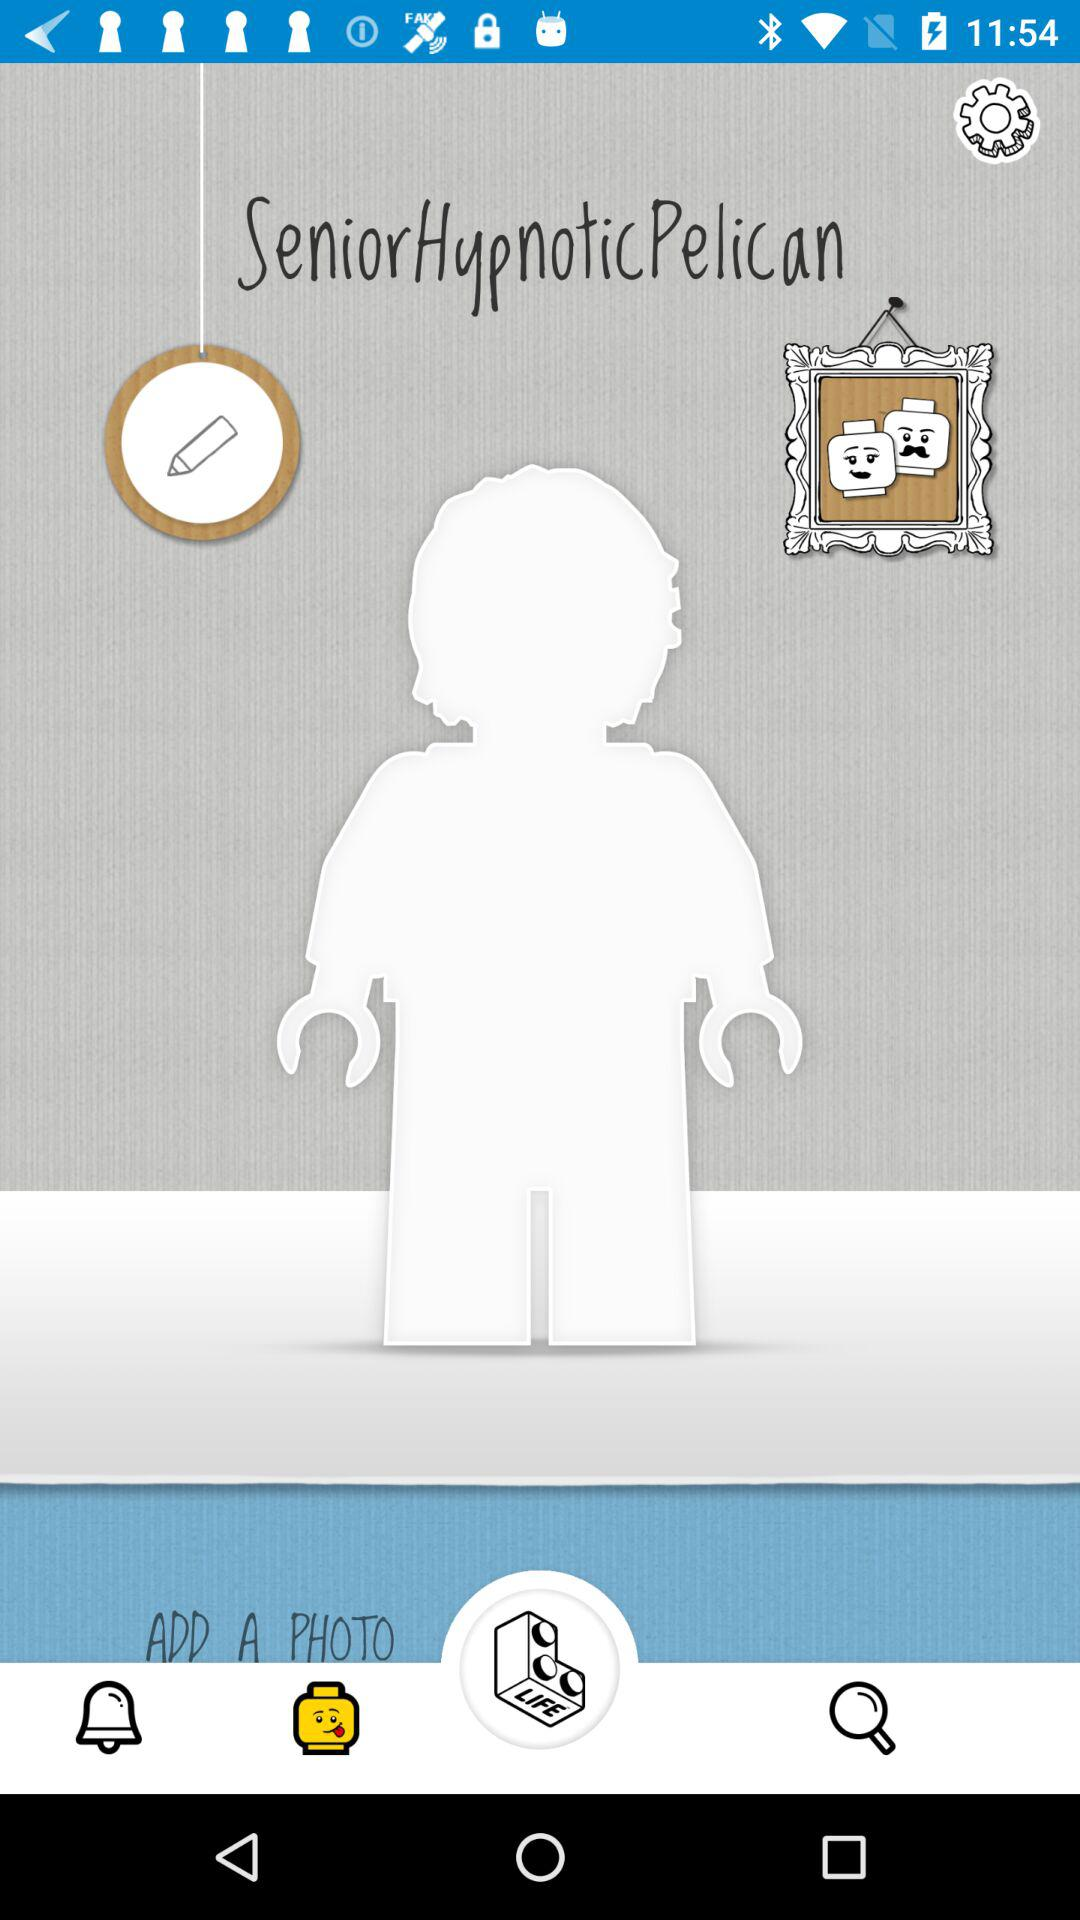From where is the user adding a photo?
When the provided information is insufficient, respond with <no answer>. <no answer> 